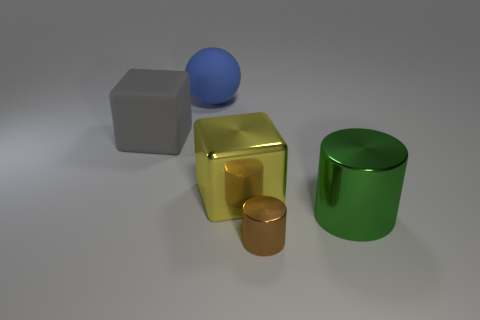There is a object behind the big object that is on the left side of the big rubber object that is behind the gray cube; what shape is it?
Your answer should be very brief. Sphere. There is a object that is to the left of the shiny cube and to the right of the gray matte thing; what material is it?
Offer a terse response. Rubber. What number of cyan shiny cubes have the same size as the rubber cube?
Your answer should be compact. 0. What number of shiny things are large gray things or small cylinders?
Your answer should be compact. 1. What is the material of the blue ball?
Your response must be concise. Rubber. How many green shiny things are in front of the brown metal object?
Your answer should be compact. 0. Is the block on the left side of the blue rubber ball made of the same material as the small cylinder?
Offer a terse response. No. What number of other things are the same shape as the big yellow thing?
Make the answer very short. 1. What number of large things are yellow blocks or brown metallic spheres?
Your answer should be compact. 1. Are there any large blue objects made of the same material as the green object?
Offer a terse response. No. 